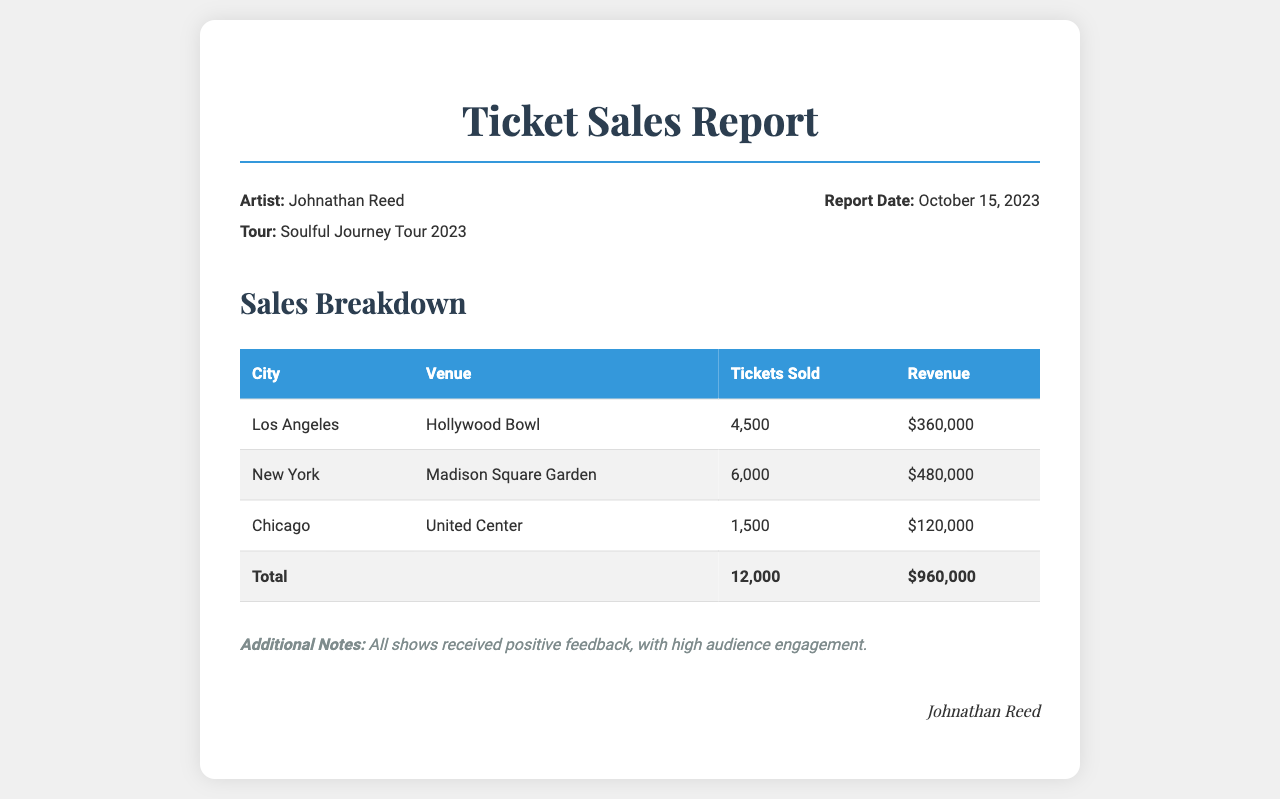What is the total number of tickets sold? The total number of tickets sold is the sum of tickets sold across all cities, which equals 4,500 + 6,000 + 1,500.
Answer: 12,000 What is the revenue generated from the New York concert? The revenue generated from the New York concert at Madison Square Garden is listed in the revenue column.
Answer: $480,000 Which venue had the highest ticket sales? By comparing the ticket sales numbers for each venue, the venue with the highest sales is identified.
Answer: Madison Square Garden What is the report date? The report date is specified in the tour information section of the document.
Answer: October 15, 2023 How many tickets were sold in Chicago? The document specifically states the number of tickets sold for the Chicago concert at United Center.
Answer: 1,500 What is the total revenue from all concerts? The total revenue is a sum of the revenue generated from all concerts listed in the document.
Answer: $960,000 Which city is associated with the Hollywood Bowl? The city associated with the Hollywood Bowl is mentioned directly in the sales breakdown table.
Answer: Los Angeles What is the total number of tickets sold for the concert in Los Angeles? The document indicates the specific ticket sales figure for the concert in Los Angeles.
Answer: 4,500 What feedback did the shows receive? The notes section of the document includes information on the audience feedback for the shows.
Answer: Positive feedback 